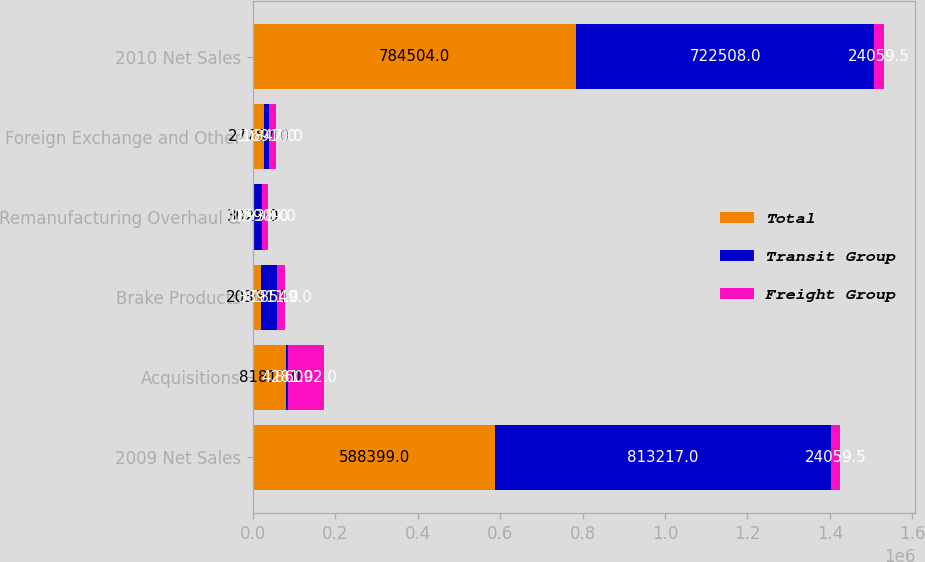Convert chart. <chart><loc_0><loc_0><loc_500><loc_500><stacked_bar_chart><ecel><fcel>2009 Net Sales<fcel>Acquisitions<fcel>Brake Products<fcel>Remanufacturing Overhaul &<fcel>Foreign Exchange and Other<fcel>2010 Net Sales<nl><fcel>Total<fcel>588399<fcel>81811<fcel>20362<fcel>3029<fcel>27757<fcel>784504<nl><fcel>Transit Group<fcel>813217<fcel>4281<fcel>38911<fcel>18938<fcel>10847<fcel>722508<nl><fcel>Freight Group<fcel>24059.5<fcel>86092<fcel>18549<fcel>15909<fcel>16910<fcel>24059.5<nl></chart> 